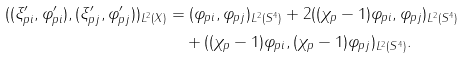<formula> <loc_0><loc_0><loc_500><loc_500>( ( \xi _ { p i } ^ { \prime } , \varphi _ { p i } ^ { \prime } ) , ( \xi _ { p j } ^ { \prime } , \varphi _ { p j } ^ { \prime } ) ) _ { L ^ { 2 } ( X ) } & = ( \varphi _ { p i } , \varphi _ { p j } ) _ { L ^ { 2 } ( S ^ { 4 } ) } + 2 ( ( \chi _ { p } - 1 ) \varphi _ { p i } , \varphi _ { p j } ) _ { L ^ { 2 } ( S ^ { 4 } ) } \\ & \quad + ( ( \chi _ { p } - 1 ) \varphi _ { p i } , ( \chi _ { p } - 1 ) \varphi _ { p j } ) _ { L ^ { 2 } ( S ^ { 4 } ) } .</formula> 